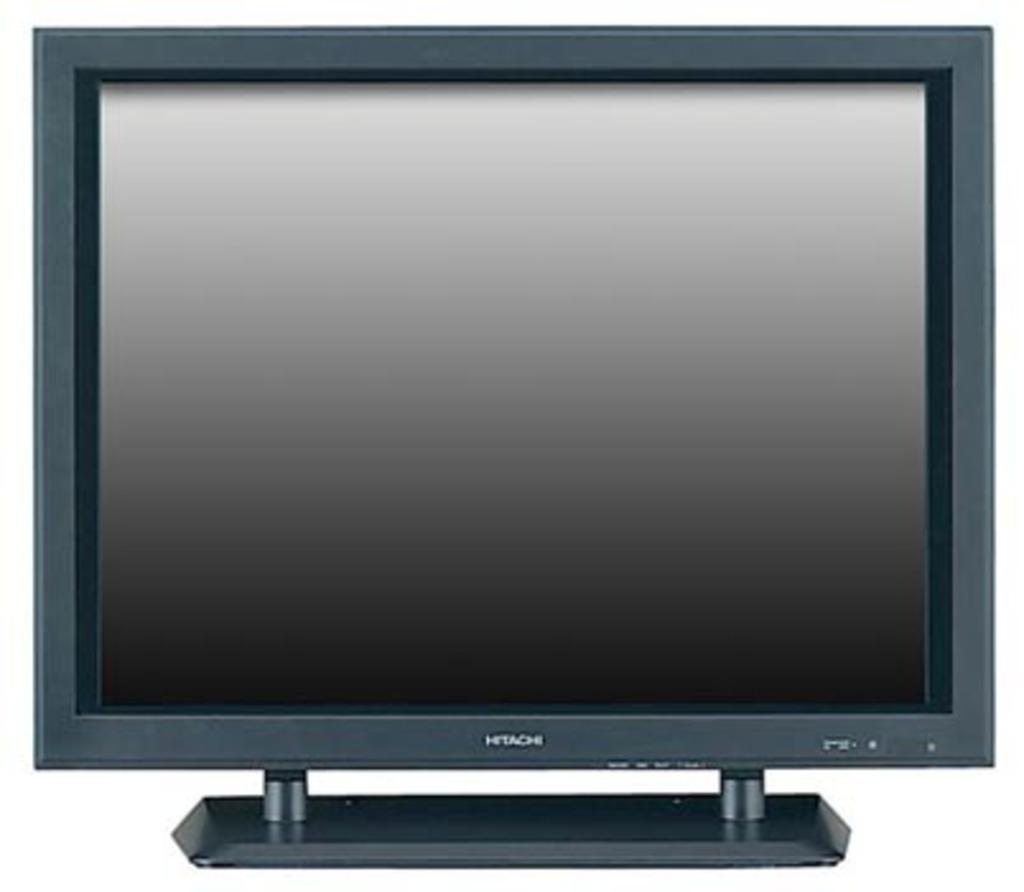<image>
Offer a succinct explanation of the picture presented. A Hitachi TV is turned off and the screen is dark. 